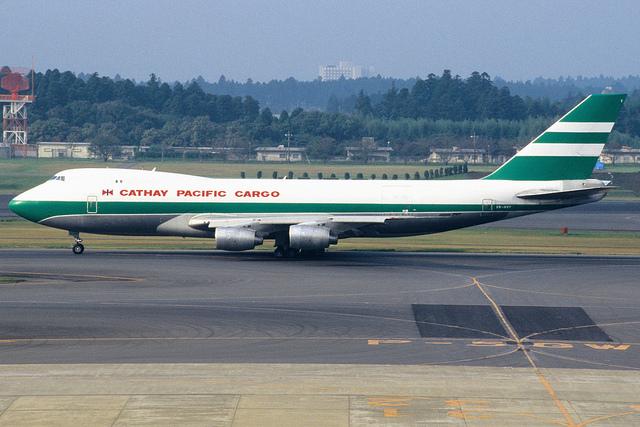What colors are the plane?
Quick response, please. Green and white. Is this a cargo plane?
Give a very brief answer. Yes. Is this a passenger plane?
Keep it brief. No. What ratio is the plane to the car?
Quick response, please. 10:1. What color is the lettering on the side of the plane?
Short answer required. Red. 